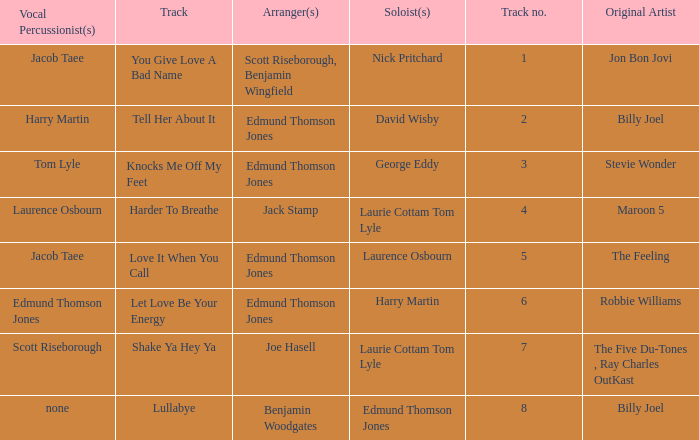Who were the original artist(s) for track number 6? Robbie Williams. 